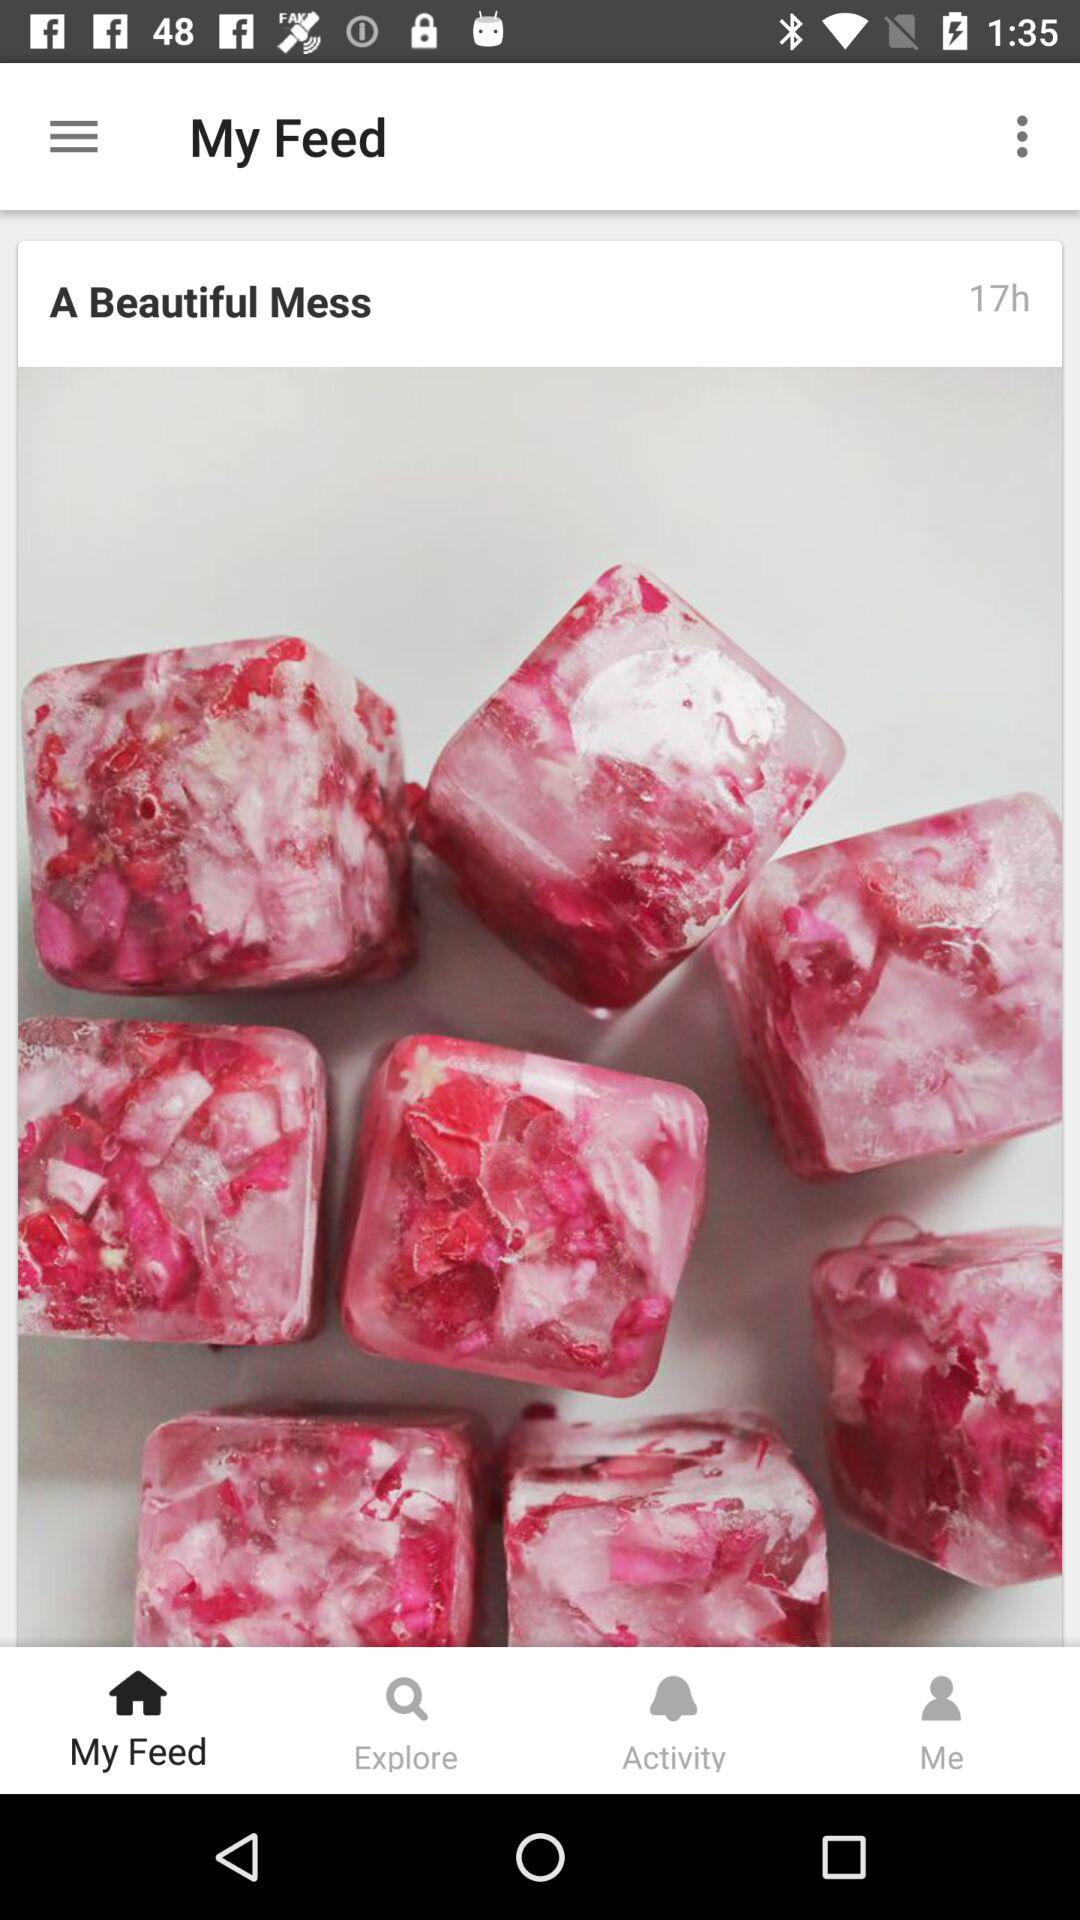What is the application name?
When the provided information is insufficient, respond with <no answer>. <no answer> 